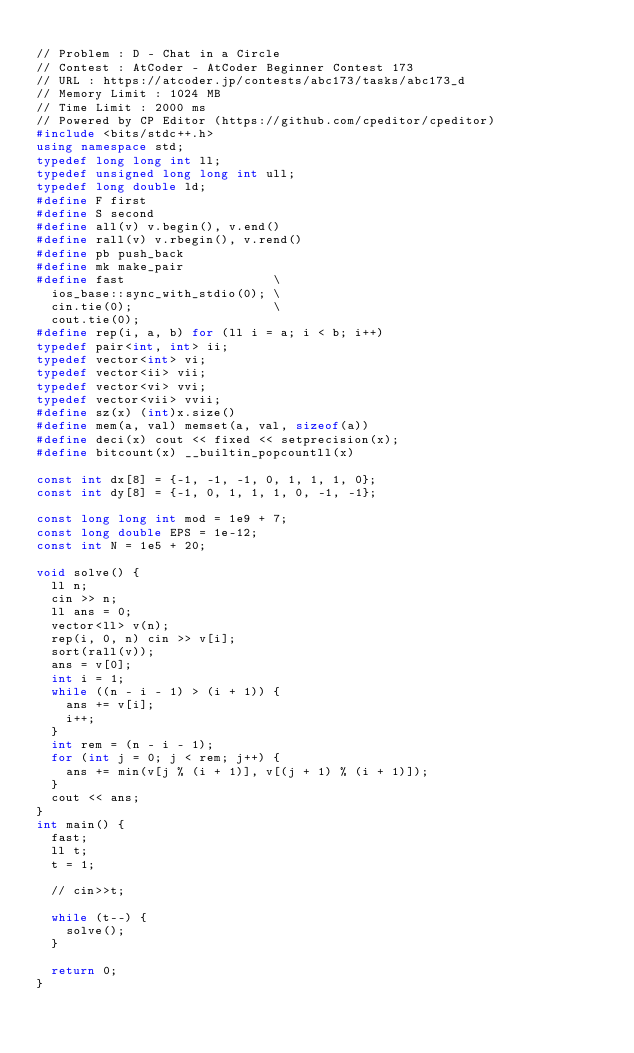Convert code to text. <code><loc_0><loc_0><loc_500><loc_500><_C++_>
// Problem : D - Chat in a Circle
// Contest : AtCoder - AtCoder Beginner Contest 173
// URL : https://atcoder.jp/contests/abc173/tasks/abc173_d
// Memory Limit : 1024 MB
// Time Limit : 2000 ms
// Powered by CP Editor (https://github.com/cpeditor/cpeditor)
#include <bits/stdc++.h>
using namespace std;
typedef long long int ll;
typedef unsigned long long int ull;
typedef long double ld;
#define F first
#define S second
#define all(v) v.begin(), v.end()
#define rall(v) v.rbegin(), v.rend()
#define pb push_back
#define mk make_pair
#define fast                    \
  ios_base::sync_with_stdio(0); \
  cin.tie(0);                   \
  cout.tie(0);
#define rep(i, a, b) for (ll i = a; i < b; i++)
typedef pair<int, int> ii;
typedef vector<int> vi;
typedef vector<ii> vii;
typedef vector<vi> vvi;
typedef vector<vii> vvii;
#define sz(x) (int)x.size()
#define mem(a, val) memset(a, val, sizeof(a))
#define deci(x) cout << fixed << setprecision(x);
#define bitcount(x) __builtin_popcountll(x)

const int dx[8] = {-1, -1, -1, 0, 1, 1, 1, 0};
const int dy[8] = {-1, 0, 1, 1, 1, 0, -1, -1};

const long long int mod = 1e9 + 7;
const long double EPS = 1e-12;
const int N = 1e5 + 20;

void solve() {
  ll n;
  cin >> n;
  ll ans = 0;
  vector<ll> v(n);
  rep(i, 0, n) cin >> v[i];
  sort(rall(v));
  ans = v[0];
  int i = 1;
  while ((n - i - 1) > (i + 1)) {
    ans += v[i];
    i++;
  }
  int rem = (n - i - 1);
  for (int j = 0; j < rem; j++) {
    ans += min(v[j % (i + 1)], v[(j + 1) % (i + 1)]);
  }
  cout << ans;
}
int main() {
  fast;
  ll t;
  t = 1;

  // cin>>t;

  while (t--) {
    solve();
  }

  return 0;
}
</code> 